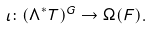Convert formula to latex. <formula><loc_0><loc_0><loc_500><loc_500>\iota \colon ( \Lambda ^ { * } T ) ^ { G } \to \Omega ( F ) .</formula> 